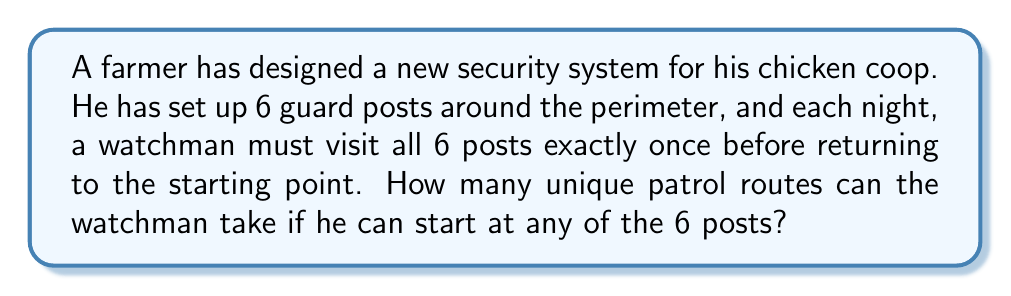Solve this math problem. Let's approach this step-by-step:

1) This problem is a variation of the traveling salesman problem, where we need to find the number of possible Hamiltonian cycles in a complete graph with 6 vertices.

2) First, let's consider how many ways the watchman can choose his starting point:
   - There are 6 possible starting points.

3) Once the starting point is chosen, we need to arrange the remaining 5 posts in a sequence:
   - This is a permutation of 5 elements, which is calculated as $5!$.

4) However, for each starting point and permutation of the other 5 posts, there are two equivalent routes:
   - Clockwise: 1 → 2 → 3 → 4 → 5 → 6 → 1
   - Counterclockwise: 1 → 6 → 5 → 4 → 3 → 2 → 1
   These routes are considered the same in this context.

5) Therefore, we need to divide our total by 2 to account for this double-counting.

6) The final formula is:

   $$ \text{Number of unique routes} = \frac{6 \times 5!}{2} $$

7) Let's calculate:
   $$ \frac{6 \times 5!}{2} = \frac{6 \times 120}{2} = 360 $$

Thus, there are 360 unique patrol routes the watchman can take.
Answer: 360 